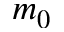Convert formula to latex. <formula><loc_0><loc_0><loc_500><loc_500>m _ { 0 }</formula> 